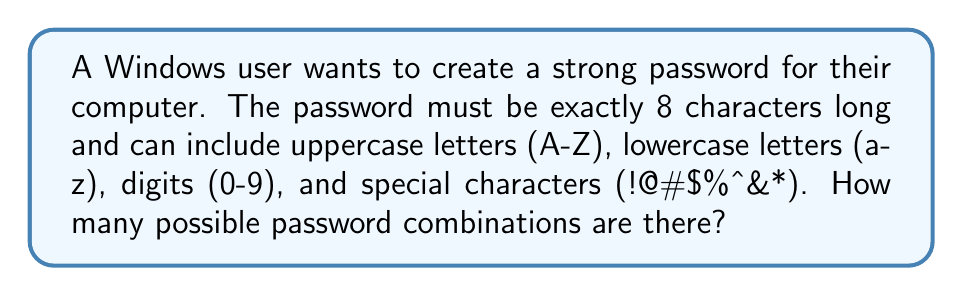Could you help me with this problem? Let's break this down step-by-step:

1) First, we need to count the number of possible characters:
   - 26 uppercase letters
   - 26 lowercase letters
   - 10 digits
   - 8 special characters
   Total: 26 + 26 + 10 + 8 = 70 possible characters

2) Now, for each of the 8 positions in the password, we have 70 choices.

3) This is a classic example of the multiplication principle. When we have independent choices, we multiply the number of possibilities for each choice.

4) Therefore, the total number of possible passwords is:

   $$ 70 \times 70 \times 70 \times 70 \times 70 \times 70 \times 70 \times 70 = 70^8 $$

5) Calculate this:
   $$ 70^8 = 576,480,100,000,000,000 $$

This is approximately 576.5 quadrillion possible combinations.
Answer: $70^8$ or 576,480,100,000,000,000 